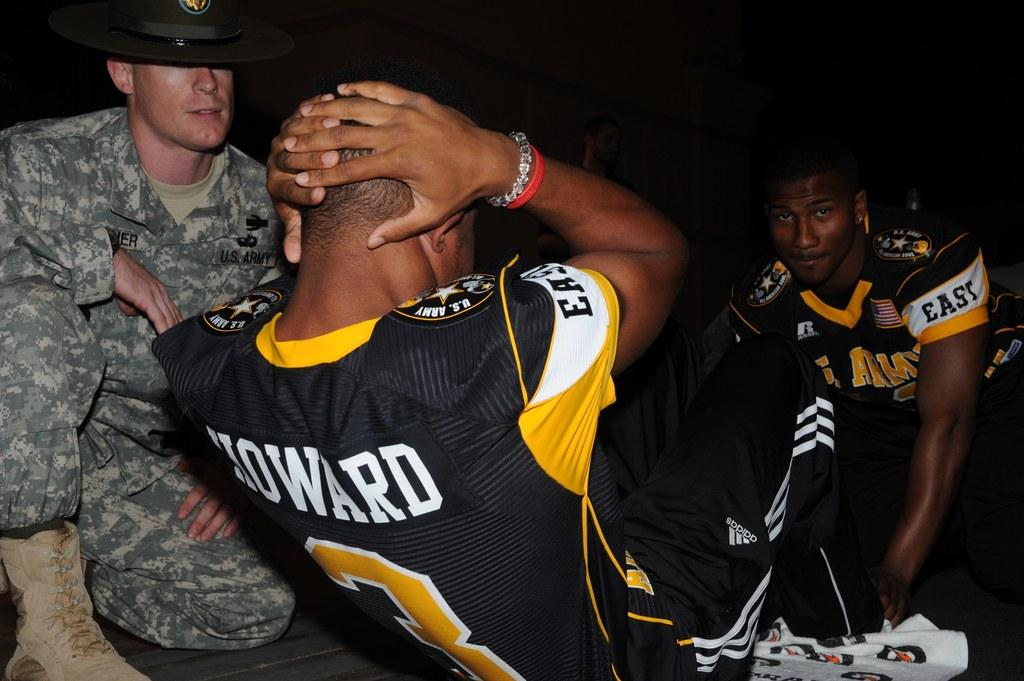Provide a one-sentence caption for the provided image. Football player Howard is doing situps with the help of a teammate while a man in a U.S. Army uniform watches. 